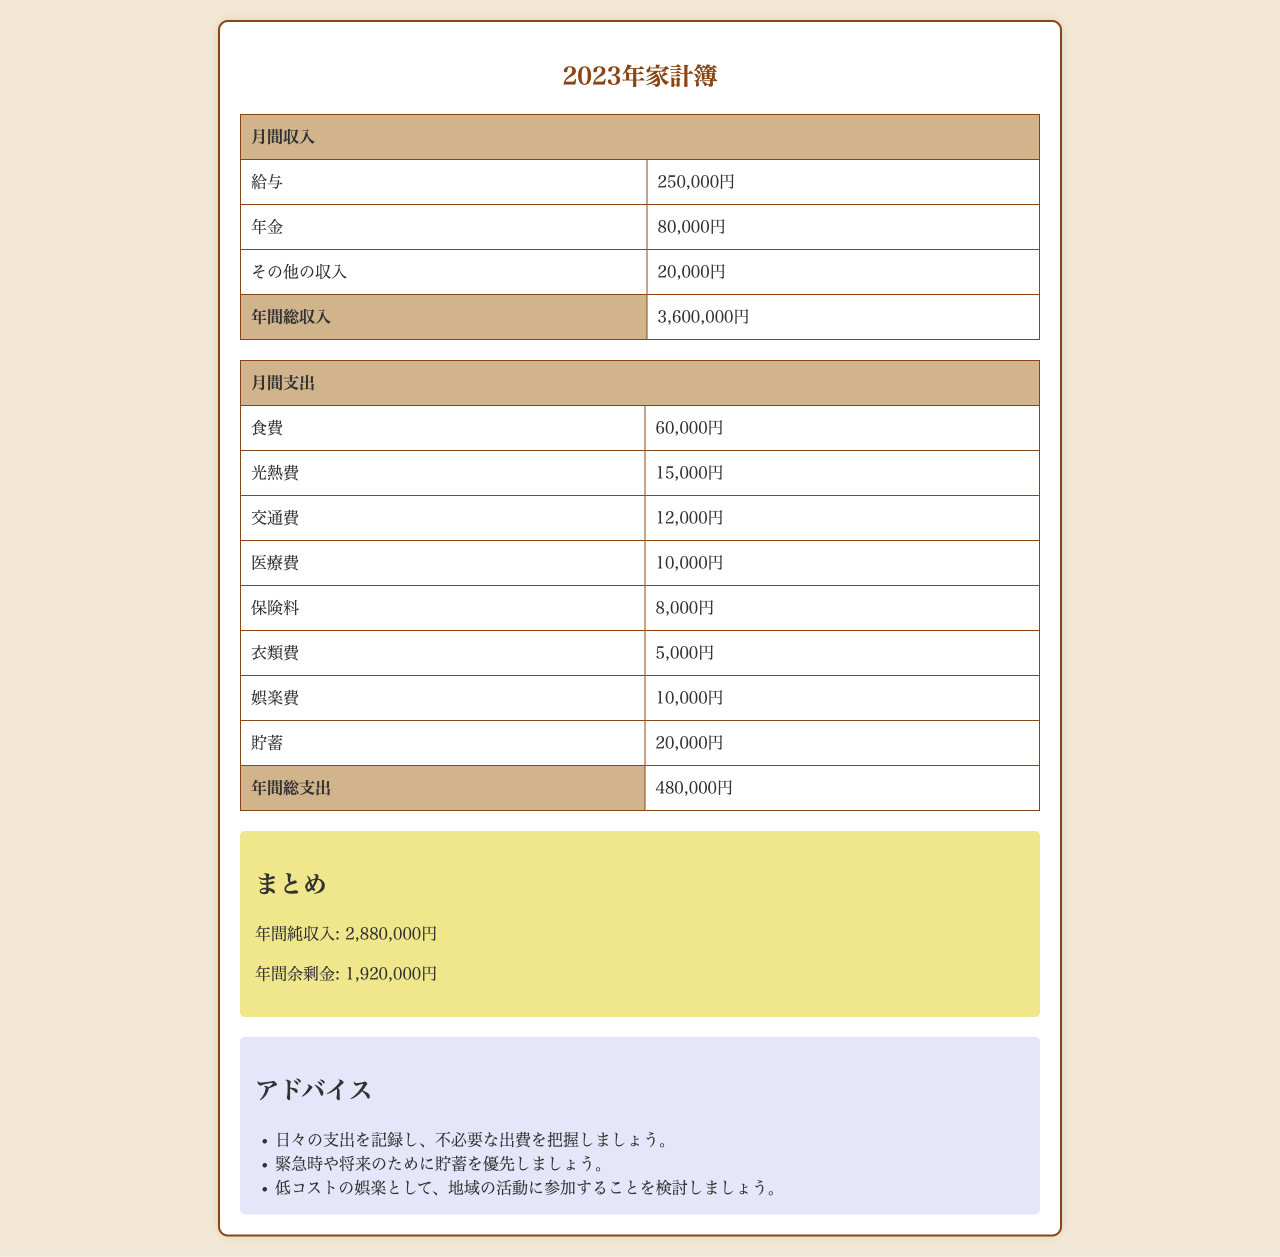What is the total monthly income? The total monthly income is the sum of monthly salary, pension, and other income, which is 250,000 yen + 80,000 yen + 20,000 yen = 350,000 yen.
Answer: 350,000円 What is the total annual expense? The total annual expense is listed in the document as the sum of all monthly expenses, which totals to 480,000 yen for the year.
Answer: 480,000円 How much is allocated for food expenses monthly? The document specifies that food expenses are 60,000 yen each month, which is a part of the total monthly expenditures.
Answer: 60,000円 What is the annual net income? The annual net income is calculated by subtracting total annual expenses from total annual income, which is 3,600,000 yen - 480,000 yen = 3,120,000 yen.
Answer: 3,120,000円 How much is saved each month? The document states that monthly savings are 20,000 yen, which is part of the monthly expense breakdown.
Answer: 20,000円 What is the total for medical expenses monthly? The monthly medical expenses listed in the document total to 10,000 yen, which is part of the health-related expenditures.
Answer: 10,000円 What year is the budget plan for? The title of the document indicates that the budget plan is for the year 2023.
Answer: 2023年 How much is spent on entertainment monthly? The document details entertainment expenses are 10,000 yen each month, categorized under leisure spending.
Answer: 10,000円 